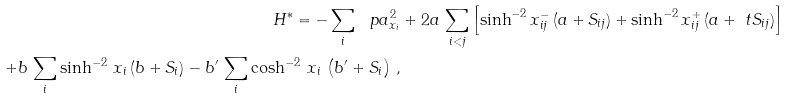Convert formula to latex. <formula><loc_0><loc_0><loc_500><loc_500>H ^ { * } = - \sum _ { i } \ p a _ { x _ { i } } ^ { 2 } & + 2 a \, \sum _ { i < j } \left [ \sinh ^ { - 2 } x _ { i j } ^ { - } \, ( a + S _ { i j } ) + \sinh ^ { - 2 } x _ { i j } ^ { + } \, ( a + \ t S _ { i j } ) \right ] \\ + b \, \sum _ { i } \sinh ^ { - 2 } \, x _ { i } \, ( b + S _ { i } ) - b ^ { \prime } \, \sum _ { i } \cosh ^ { - 2 } \, x _ { i } \, \left ( b ^ { \prime } + S _ { i } \right ) \, ,</formula> 